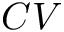Convert formula to latex. <formula><loc_0><loc_0><loc_500><loc_500>C V</formula> 